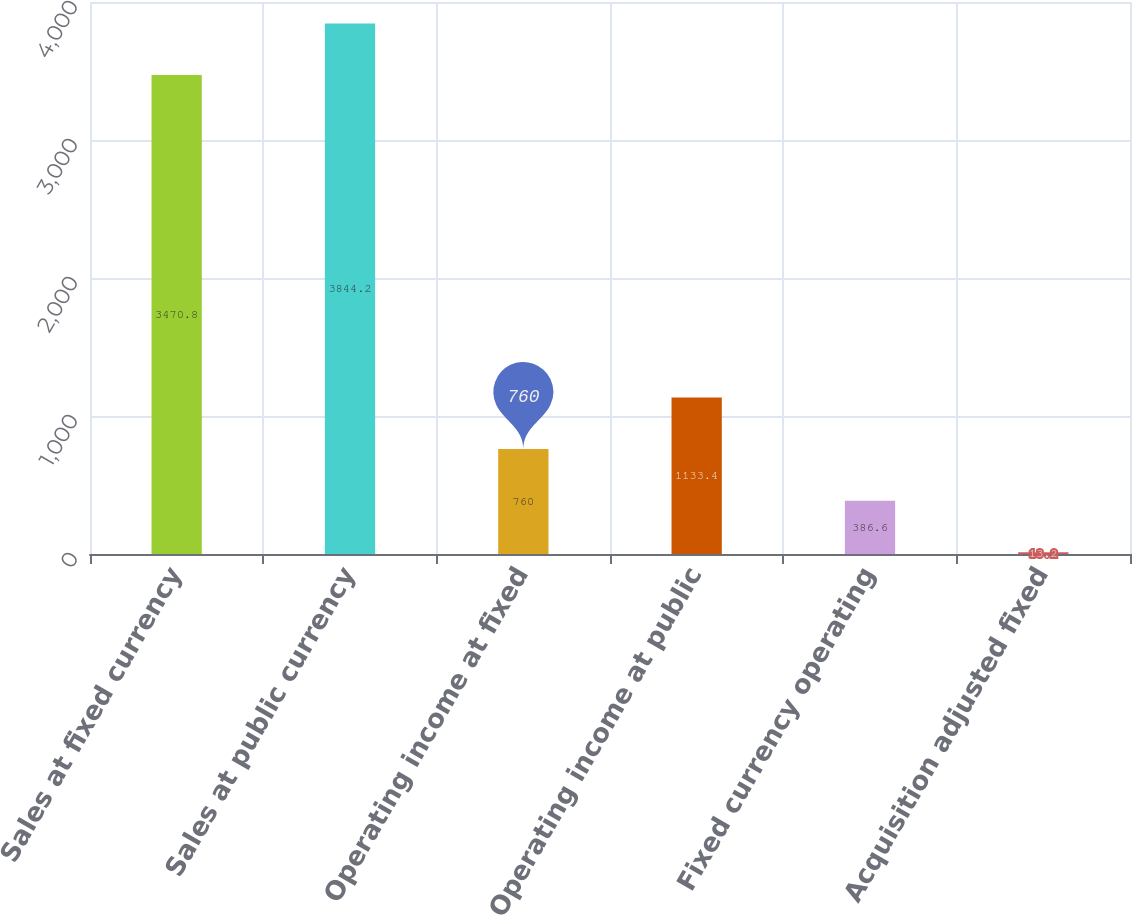Convert chart to OTSL. <chart><loc_0><loc_0><loc_500><loc_500><bar_chart><fcel>Sales at fixed currency<fcel>Sales at public currency<fcel>Operating income at fixed<fcel>Operating income at public<fcel>Fixed currency operating<fcel>Acquisition adjusted fixed<nl><fcel>3470.8<fcel>3844.2<fcel>760<fcel>1133.4<fcel>386.6<fcel>13.2<nl></chart> 